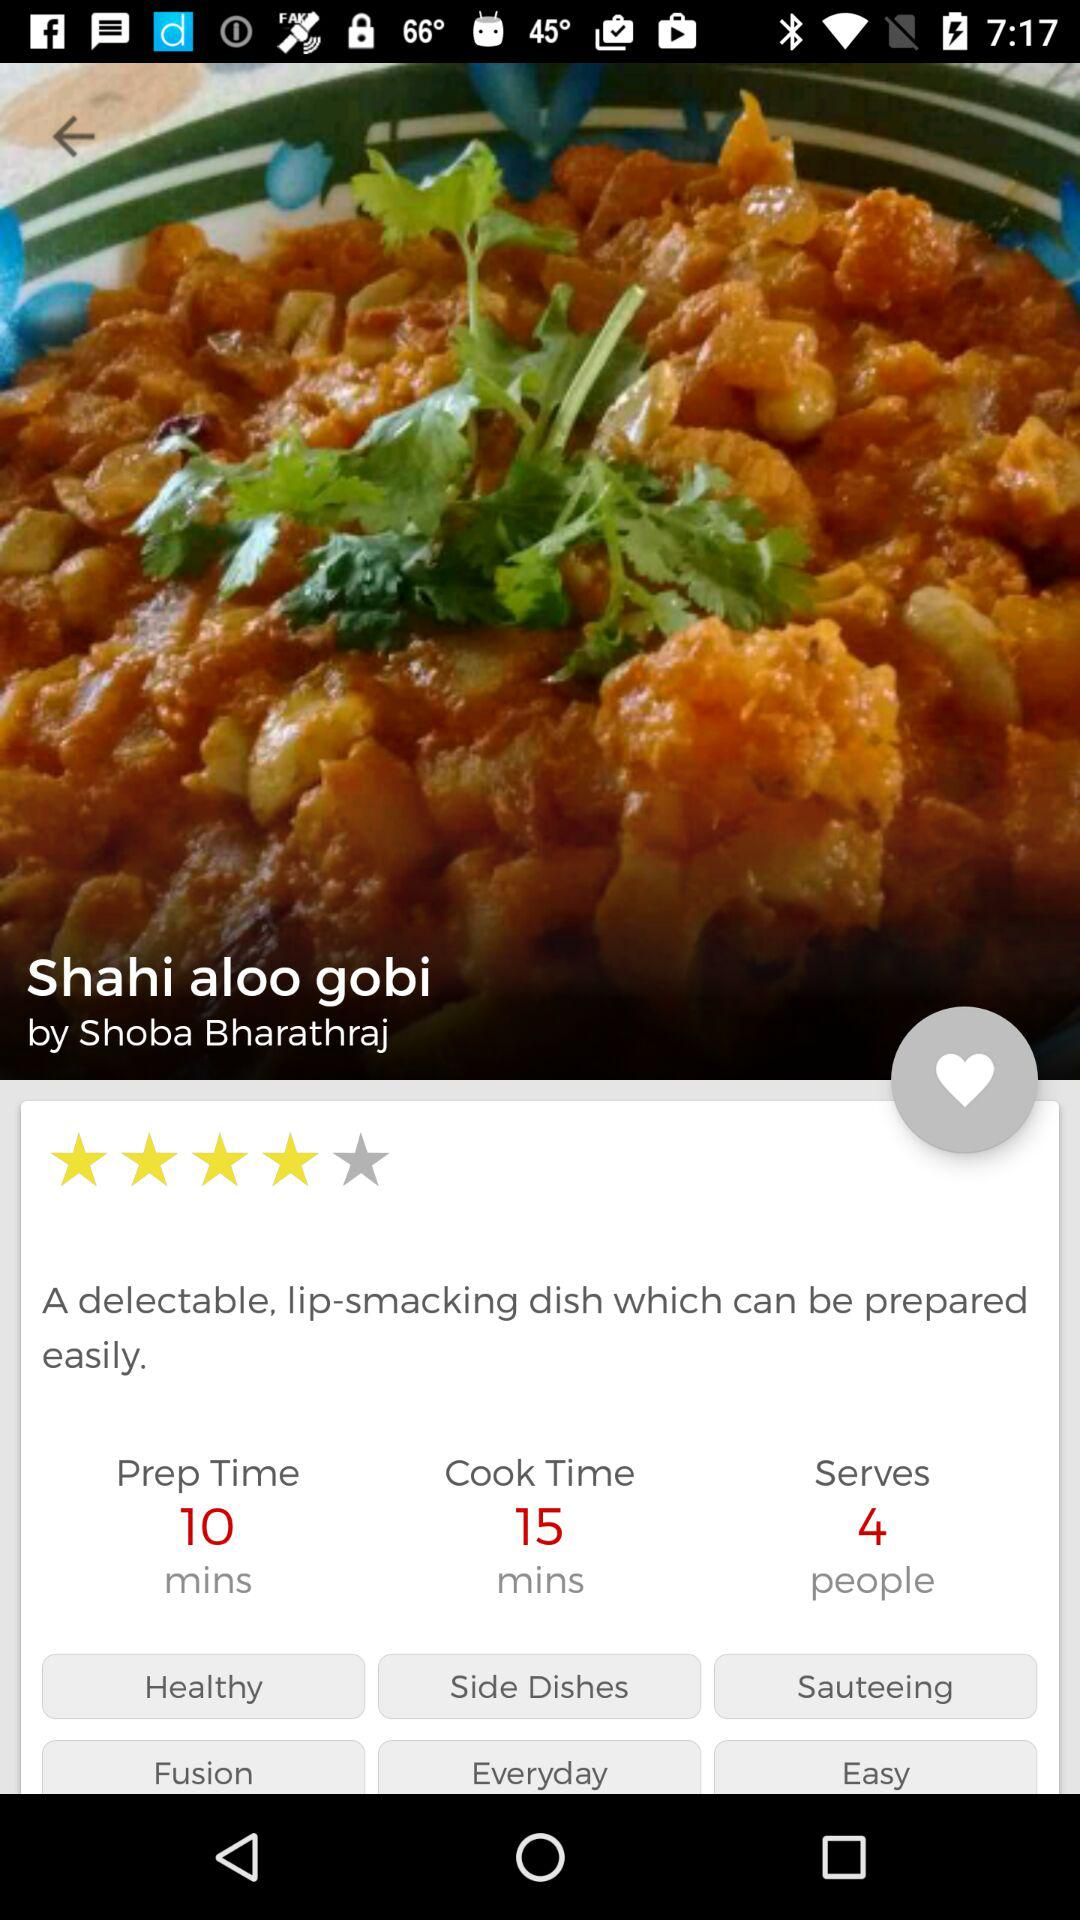How many more minutes does it take to cook the dish than to prepare it?
Answer the question using a single word or phrase. 5 